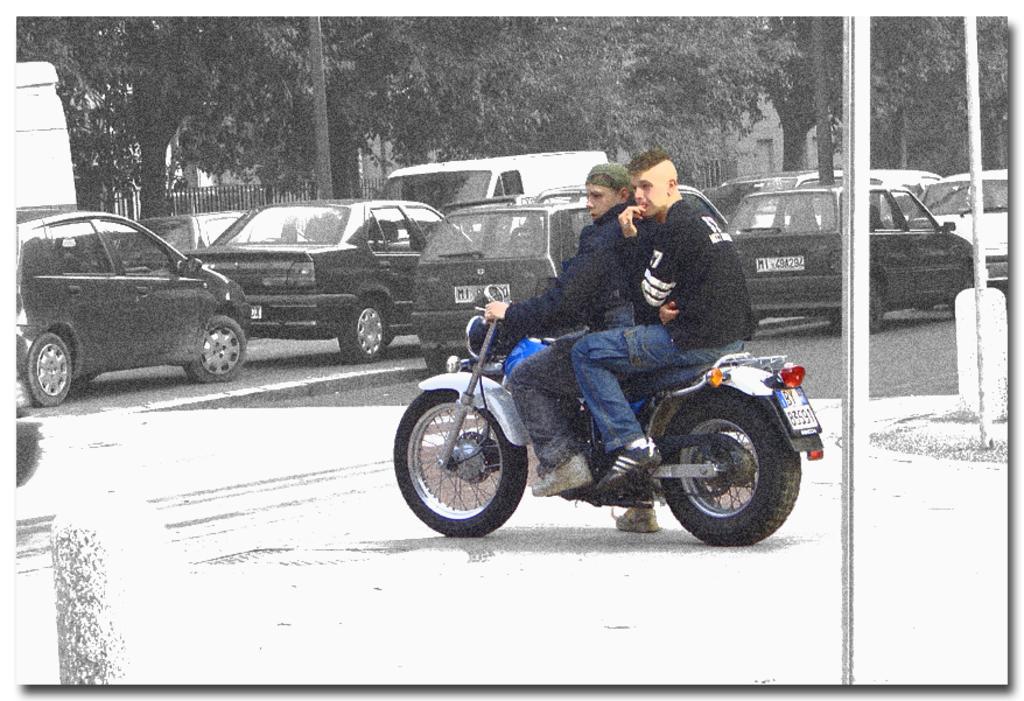In one or two sentences, can you explain what this image depicts? In this image we can see the road so many vehicles are moving and one motorcycle is there two persons are raiding at the side of the road we can see so many trees and buildings. 